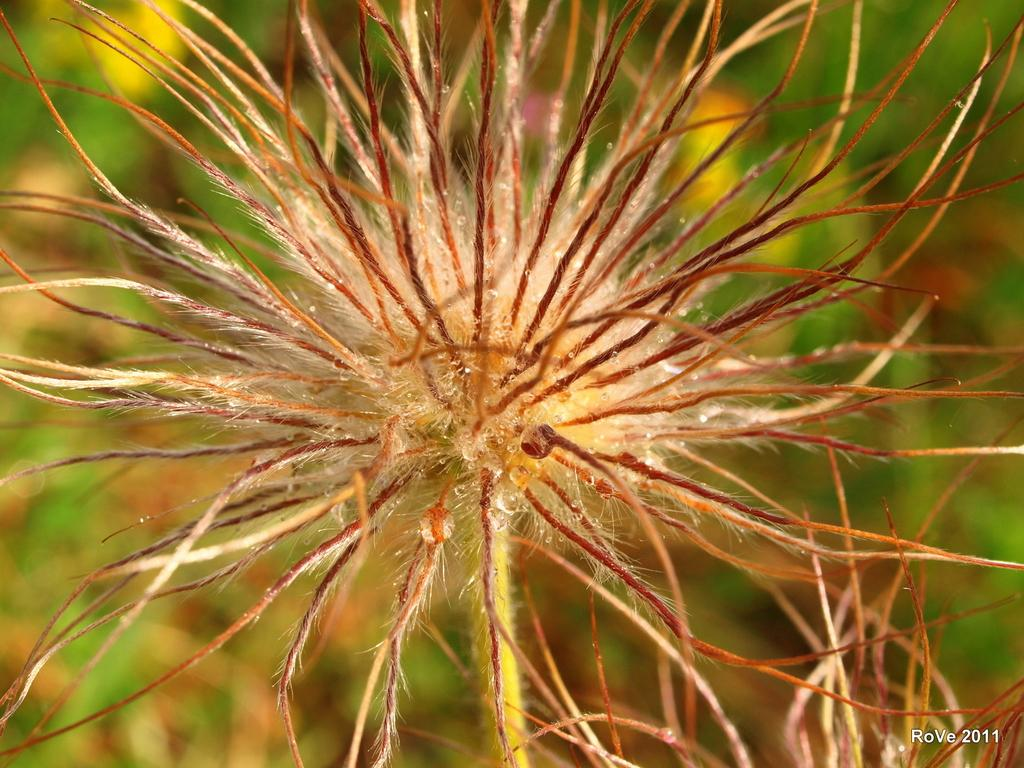What is the main subject of the image? There is a flower in the image. Can you describe the background of the image? The background of the image is blurred. What type of fork is used to eat the meal in the image? There is no meal or fork present in the image; it features a flower with a blurred background. 